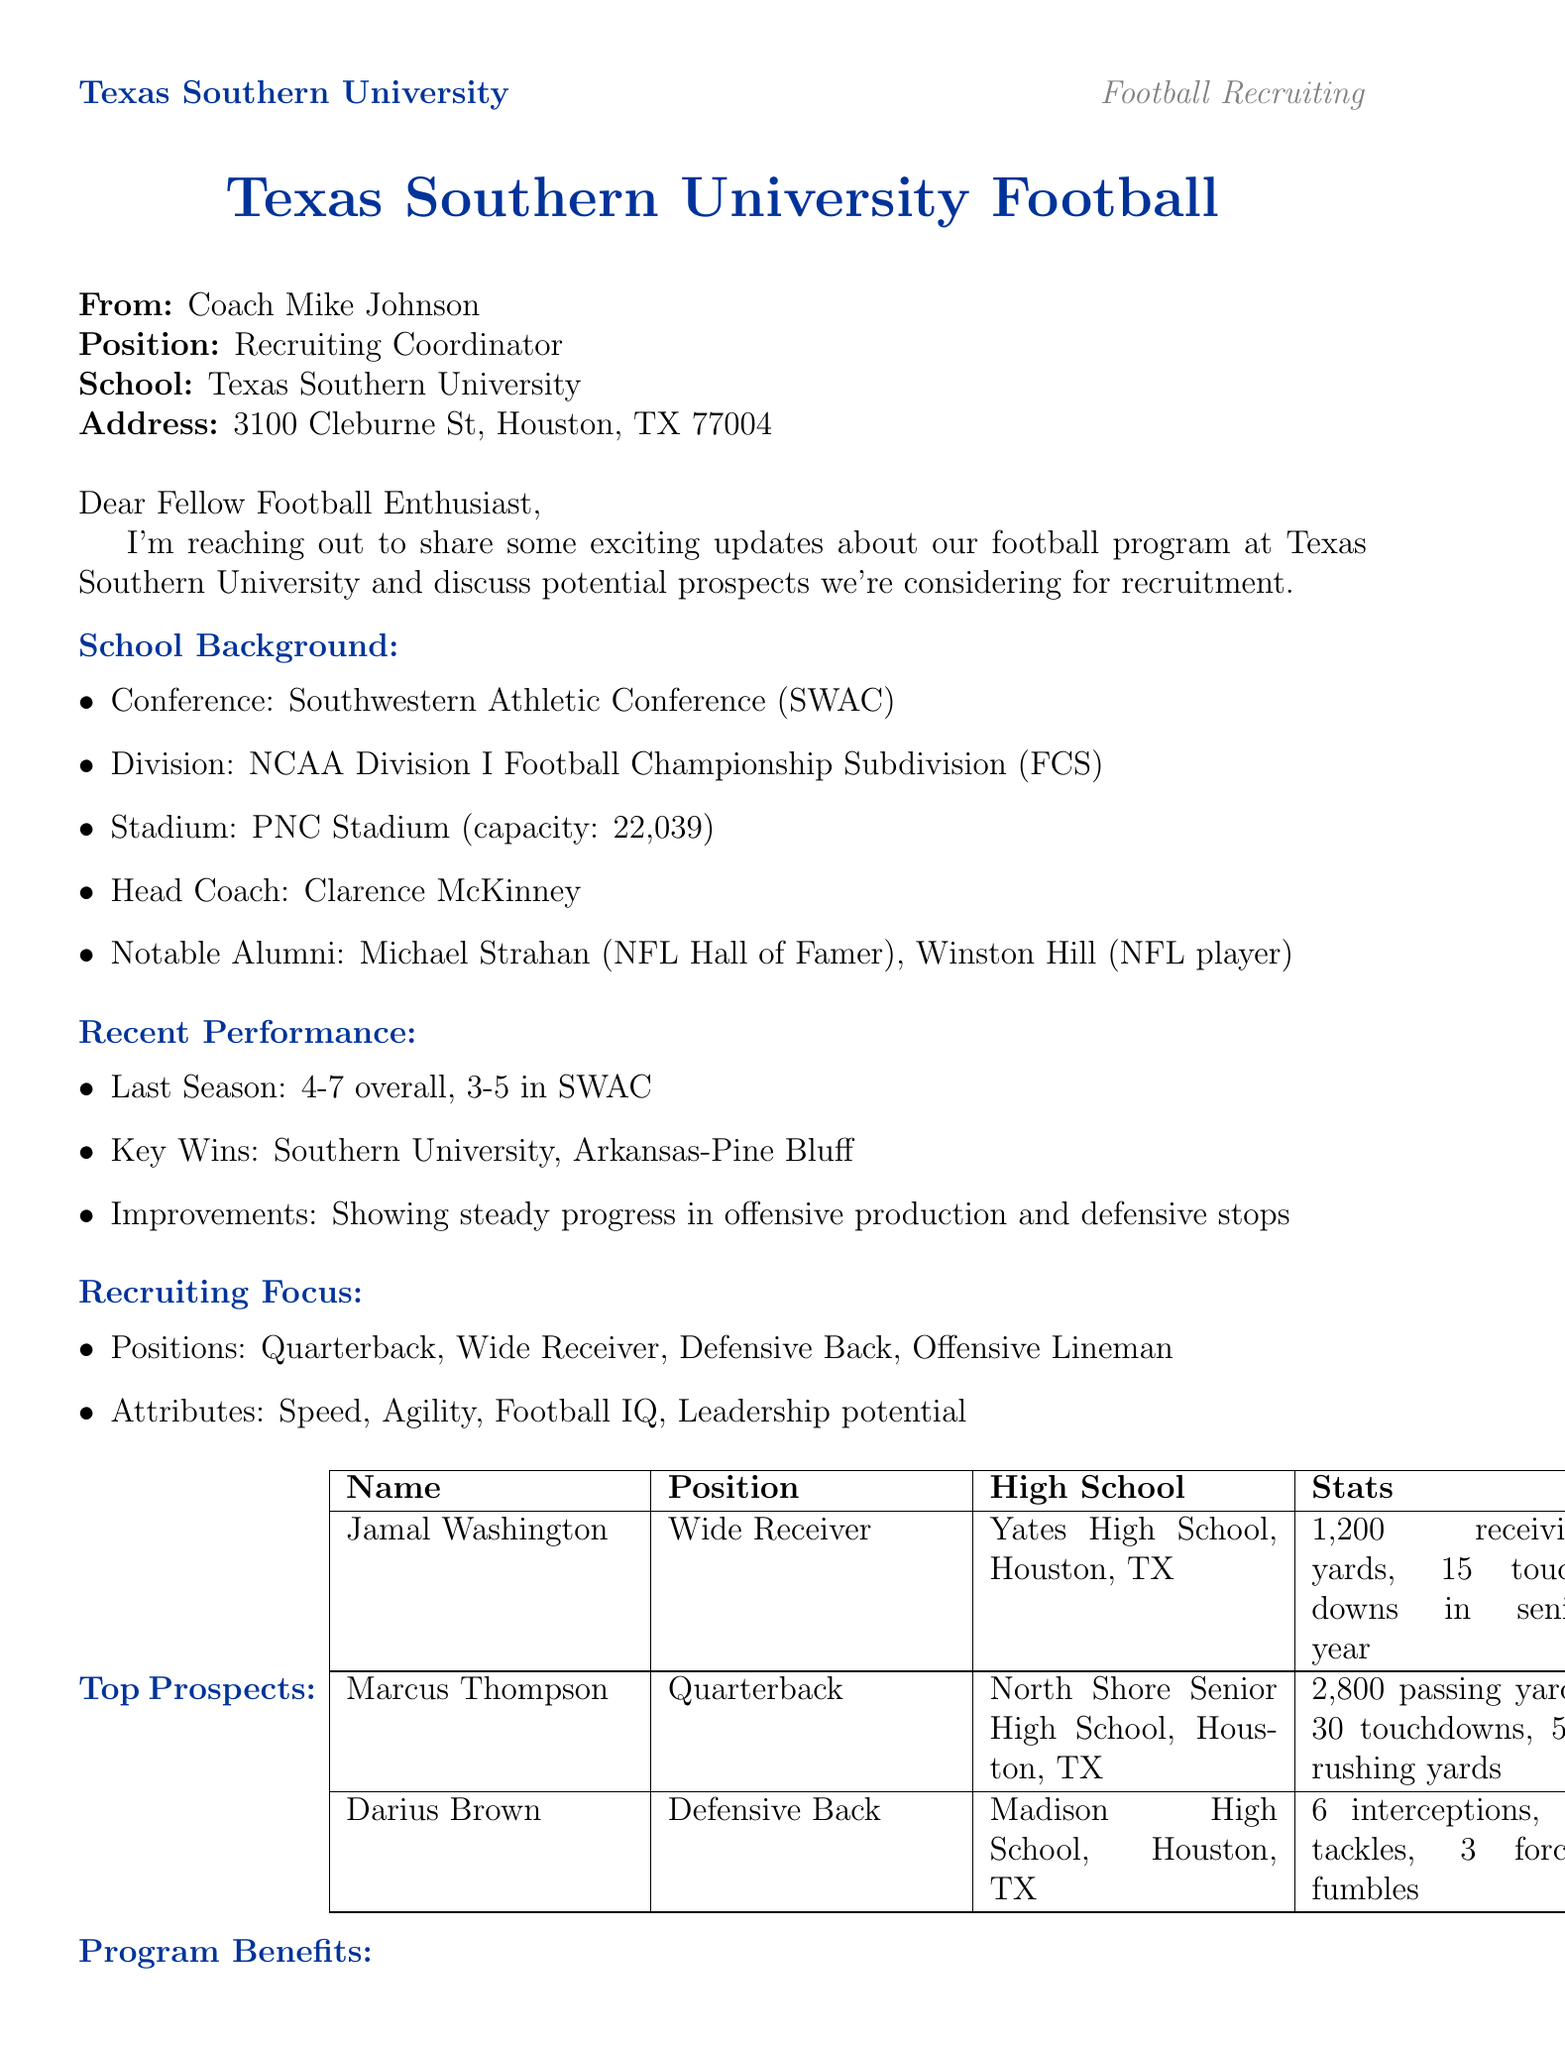What is the name of the head coach? The letter states that the head coach is Clarence McKinney.
Answer: Clarence McKinney What is the overall record from last season? The document mentions the last season's record was 4-7 overall.
Answer: 4-7 What is the capacity of PNC Stadium? The stadium's capacity is indicated as 22,039.
Answer: 22,039 Which conference does Texas Southern University belong to? The document states that the university is in the Southwestern Athletic Conference (SWAC).
Answer: Southwestern Athletic Conference (SWAC) What position is Jamal Washington being recruited for? The letter clearly specifies that Jamal Washington is a wide receiver.
Answer: Wide Receiver What are two attributes Texas Southern University is looking for in recruits? The document lists speed and football IQ as attributes of focus for recruitment.
Answer: Speed, Football IQ When is the Summer Football Camp scheduled? According to the letter, the Summer Football Camp is set for June 10-12, 2023.
Answer: June 10-12, 2023 What is one program benefit mentioned in the letter? The document highlights strong academic support for student-athletes as a benefit.
Answer: Strong academic support for student-athletes What type of event is Junior Day? The letter describes Junior Day as a campus tour and meet-and-greet with coaches and players.
Answer: Campus tour and meet-and-greet with coaches and players 